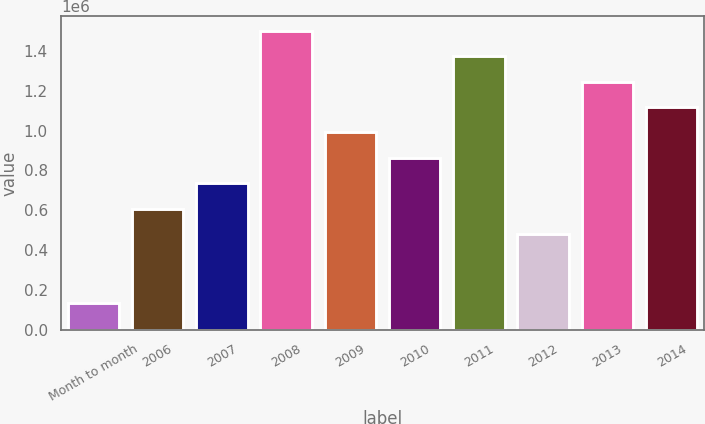Convert chart. <chart><loc_0><loc_0><loc_500><loc_500><bar_chart><fcel>Month to month<fcel>2006<fcel>2007<fcel>2008<fcel>2009<fcel>2010<fcel>2011<fcel>2012<fcel>2013<fcel>2014<nl><fcel>135000<fcel>608500<fcel>736000<fcel>1.501e+06<fcel>991000<fcel>863500<fcel>1.3735e+06<fcel>481000<fcel>1.246e+06<fcel>1.1185e+06<nl></chart> 